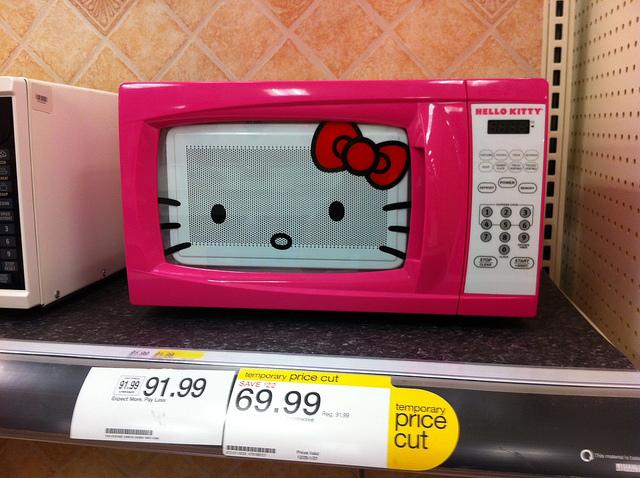How much does this item cost now?
Be succinct. 69.99. What type of machine is this?
Quick response, please. Microwave. What character is depicted on the microwave?
Quick response, please. Hello kitty. What type of appliance is this?
Be succinct. Microwave. Are these items antique?
Concise answer only. No. What does the white sign say?
Be succinct. 69.99. What does this device do?
Be succinct. Microwave. 